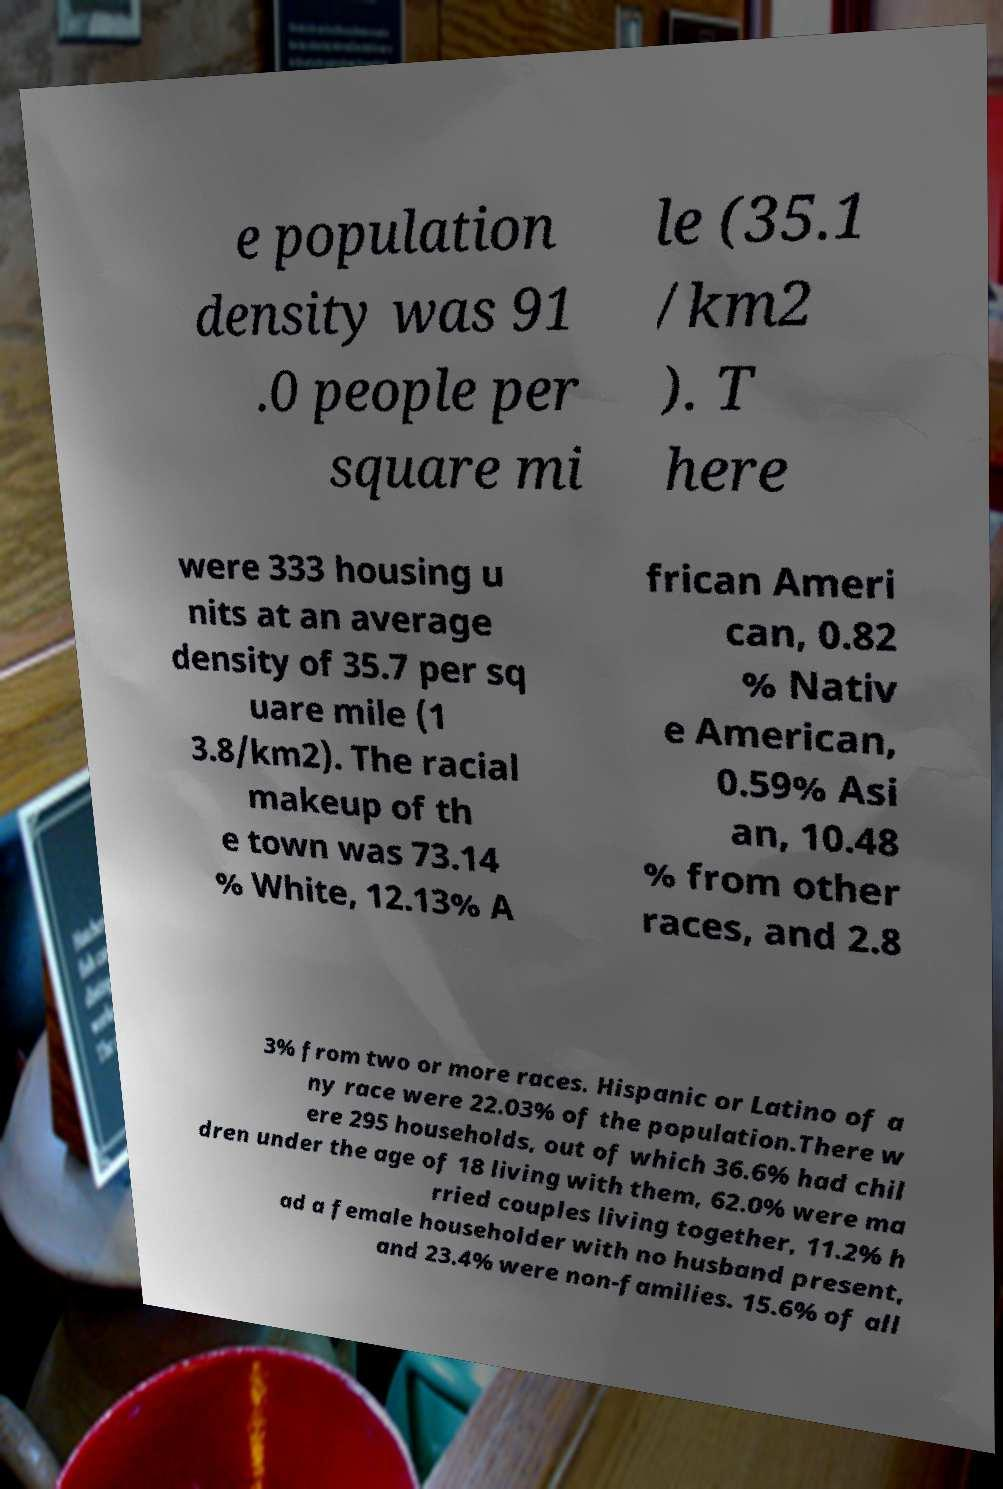Could you assist in decoding the text presented in this image and type it out clearly? e population density was 91 .0 people per square mi le (35.1 /km2 ). T here were 333 housing u nits at an average density of 35.7 per sq uare mile (1 3.8/km2). The racial makeup of th e town was 73.14 % White, 12.13% A frican Ameri can, 0.82 % Nativ e American, 0.59% Asi an, 10.48 % from other races, and 2.8 3% from two or more races. Hispanic or Latino of a ny race were 22.03% of the population.There w ere 295 households, out of which 36.6% had chil dren under the age of 18 living with them, 62.0% were ma rried couples living together, 11.2% h ad a female householder with no husband present, and 23.4% were non-families. 15.6% of all 